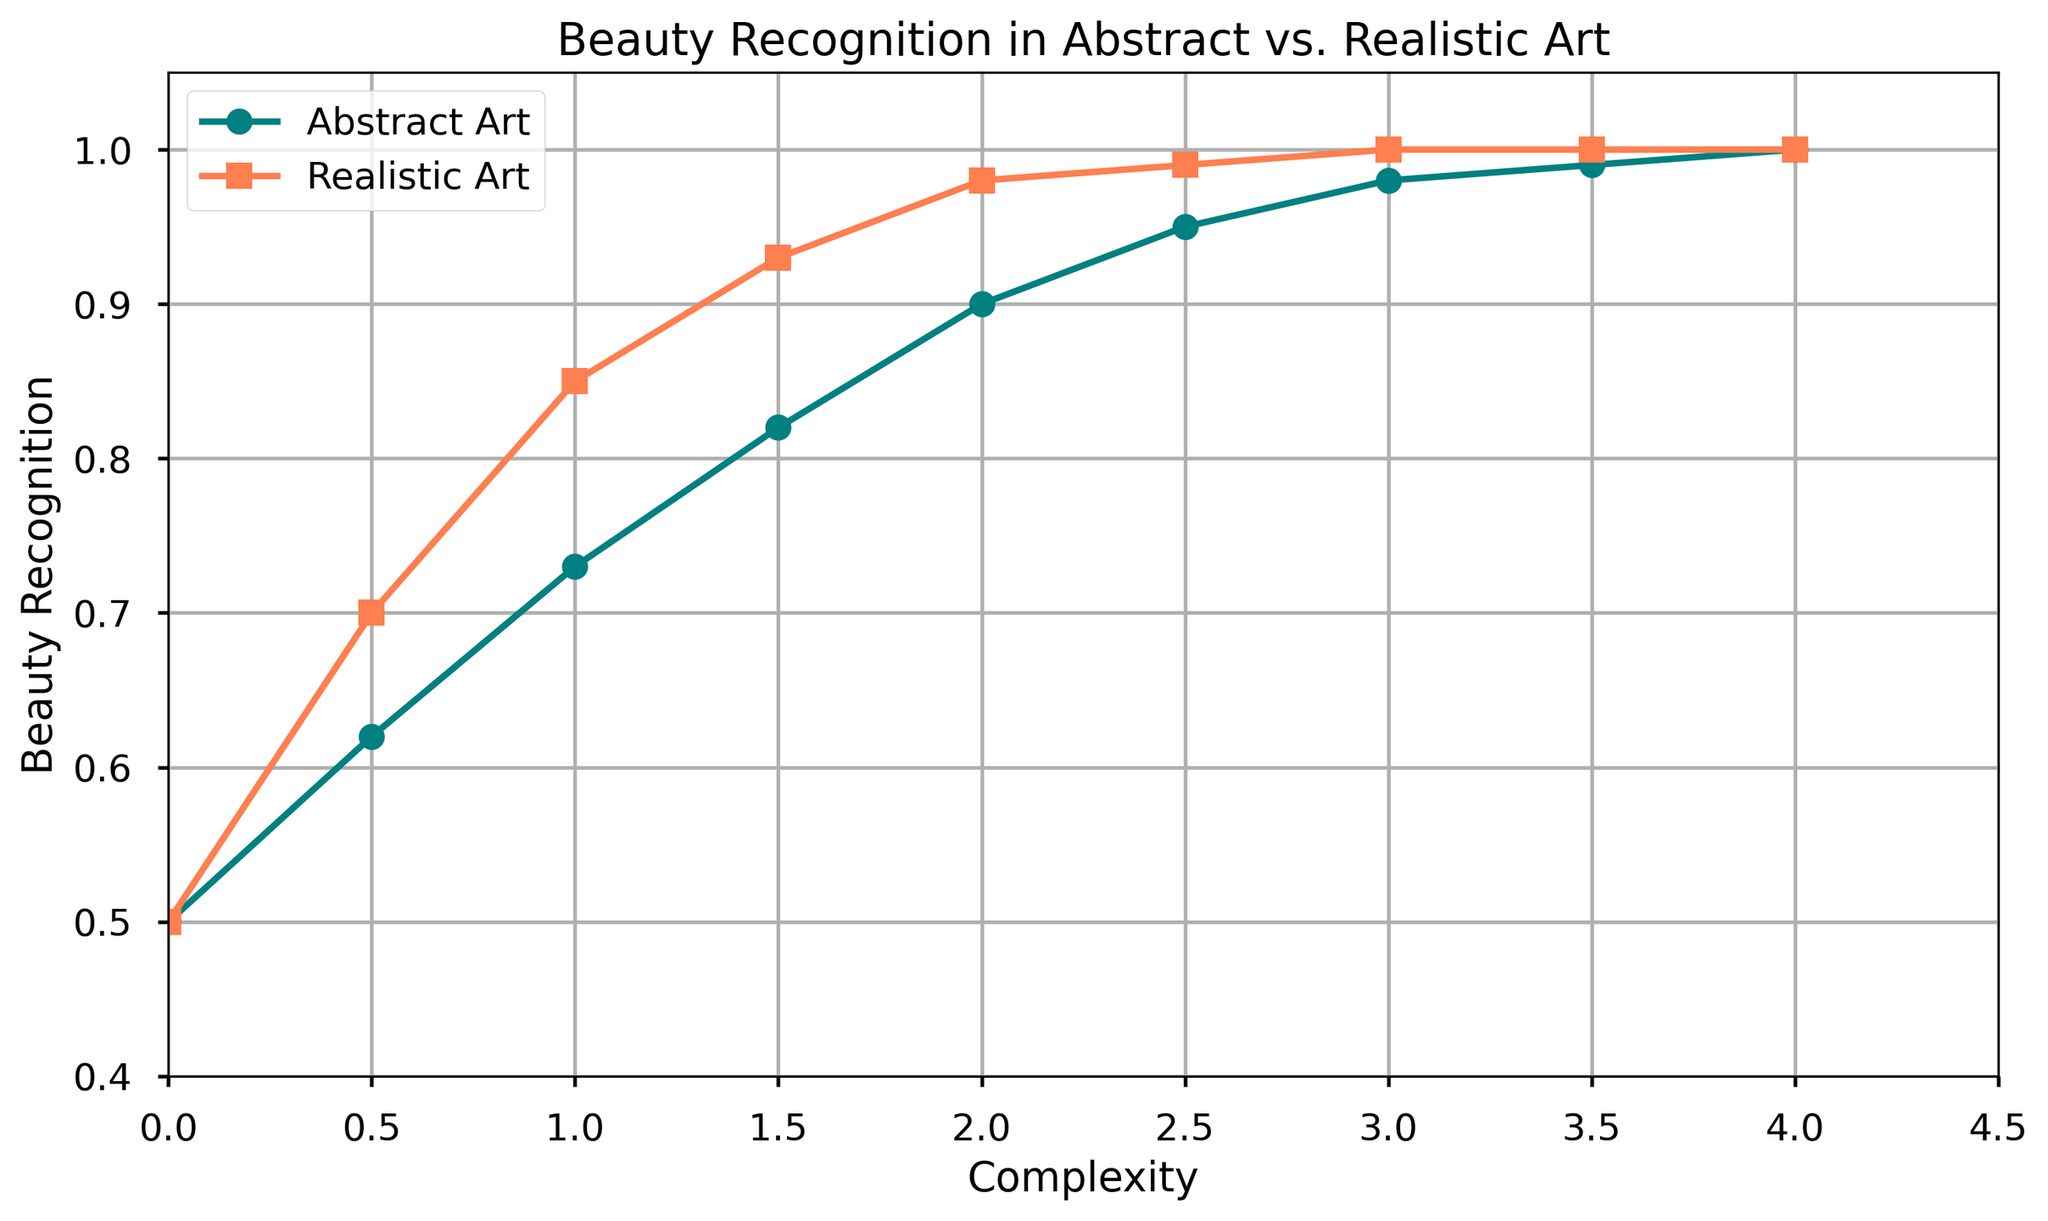What is the highest value for Beauty Recognition in the plot? Both lines for Abstract Art and Realistic Art peak at "1" for Beauty Recognition at around x=4, which is the highest value depicted in the graph.
Answer: 1 Which type of art reaches a higher Beauty Recognition value first as complexity increases? Realistic Art reaches a Beauty Recognition value of 1 faster (at x=3) compared to Abstract Art, which reaches it at around x=3.5 to 4.
Answer: Realistic Art At x = 2, which type of art has a higher Beauty Recognition value, and by how much? At x=2, Abstract Art has a Beauty Recognition value of 0.9, while Realistic Art has 0.98. The difference is 0.98 - 0.9 = 0.08.
Answer: Realistic Art by 0.08 What is the average Beauty Recognition value of Abstract Art for x values 2, 2.5, and 3? The Beauty Recognition values for Abstract Art at x=2, 2.5, and 3 are 0.9, 0.95, and 0.98. Their sum is 2.83, and the average is 2.83 / 3 = 0.9433.
Answer: 0.9433 At what x value does Abstract Art surpass a Beauty Recognition value of 0.8? Abstract Art surpasses a Beauty Recognition value of 0.8 between x=1 and x=1.5, as it is 0.73 at x=1 and 0.82 at x=1.5.
Answer: Between 1 and 1.5 At x = 1, what is the difference in Beauty Recognition between Abstract and Realistic Art? At x=1, the Beauty Recognition value for Abstract Art is 0.73, and for Realistic Art, it is 0.85. The difference is 0.85 - 0.73 = 0.12.
Answer: 0.12 How many different x values show a Beauty Recognition value of 1 for Realistic Art? The Beauty Recognition value for Realistic Art is 1 at x=3, 3.5, and 4, making a total of 3 x values.
Answer: 3 